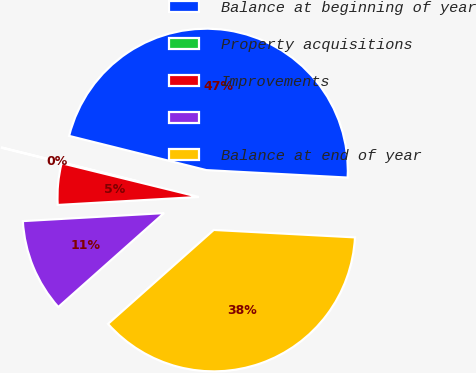Convert chart. <chart><loc_0><loc_0><loc_500><loc_500><pie_chart><fcel>Balance at beginning of year<fcel>Property acquisitions<fcel>Improvements<fcel>Unnamed: 3<fcel>Balance at end of year<nl><fcel>46.95%<fcel>0.05%<fcel>4.74%<fcel>10.66%<fcel>37.6%<nl></chart> 